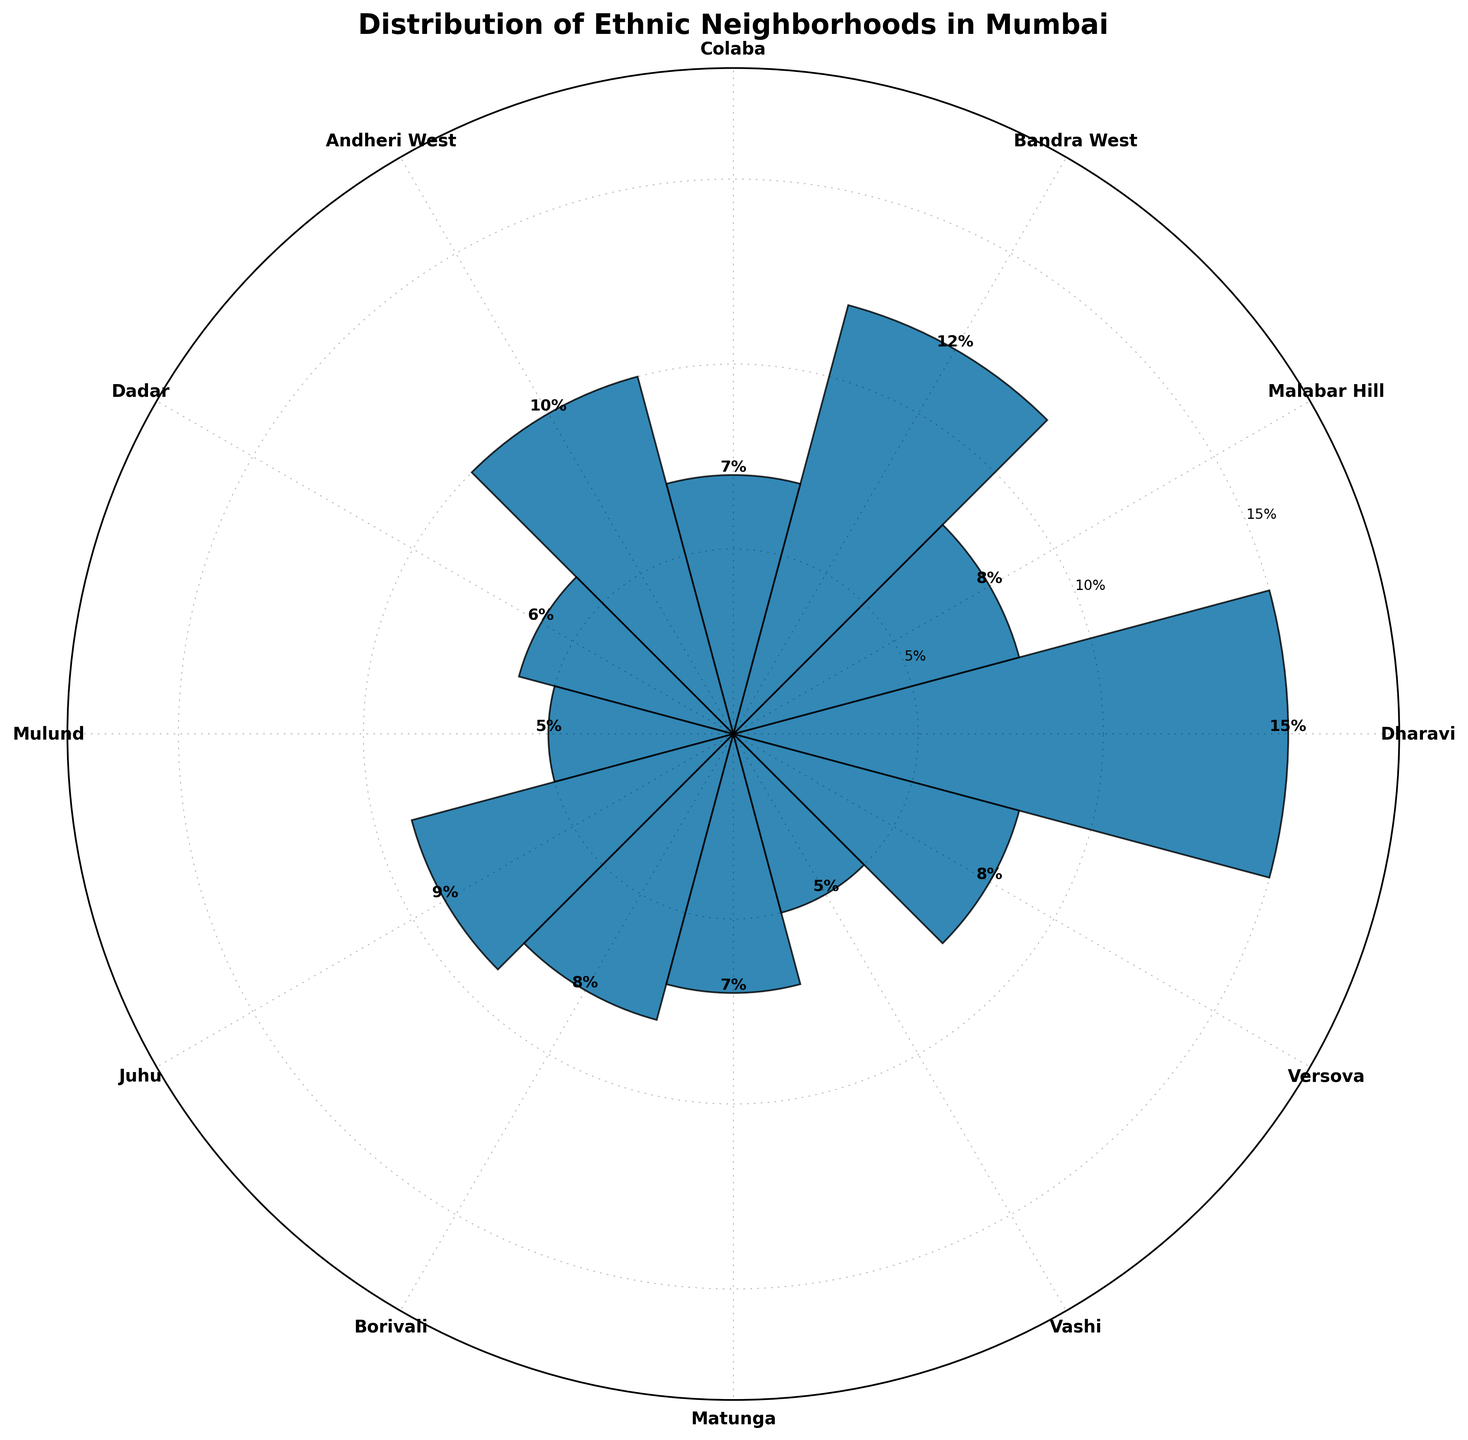How many neighborhoods are represented in the rose chart? Count the number of distinct labels around the circumference of the chart.
Answer: 12 Which neighborhood has the highest percentage? Look for the bar that extends the furthest from the center and read its label.
Answer: Dharavi What is the total percentage of Bandra West, Andheri West, and Juhu combined? Sum the percentages of Bandra West (12%), Andheri West (10%), and Juhu (9%). 12 + 10 + 9 = 31
Answer: 31% Which neighborhoods have the same percentage in the rose chart? Identify bars of equal length and read their labels.
Answer: Malabar Hill, Borivali, and Versova (each 8%) Which neighborhood has the lowest percentage? Find the shortest bar in the chart and read its label.
Answer: Mulund What is the difference in percentages between Dharavi and Dadar? Subtract the percentage of Dadar (6%) from that of Dharavi (15%). 15 - 6 = 9
Answer: 9% What is the average percentage of all neighborhoods shown? Sum all percentages and divide by the number of neighborhoods. (15 + 8 + 12 + 7 + 10 + 6 + 5 + 9 + 8 + 7 + 5 + 8) / 12 = 100 / 12 ≈ 8.33
Answer: 8.33% Is the combined percentage of Malabar Hill and Dadar greater than Bandra West? Calculate the combined percentage of Malabar Hill (8%) and Dadar (6%), and compare it with the percentage of Bandra West (12%). 8 + 6 = 14; 14 > 12
Answer: Yes How much more percentage does Juhu have compared to Vashi? Subtract the percentage of Vashi (5%) from that of Juhu (9%). 9 - 5 = 4
Answer: 4% How are the neighborhoods labeled around the chart? Identify how the labels are positioned around the circumference with respect to the bars.
Answer: In a circular manner at regular intervals 